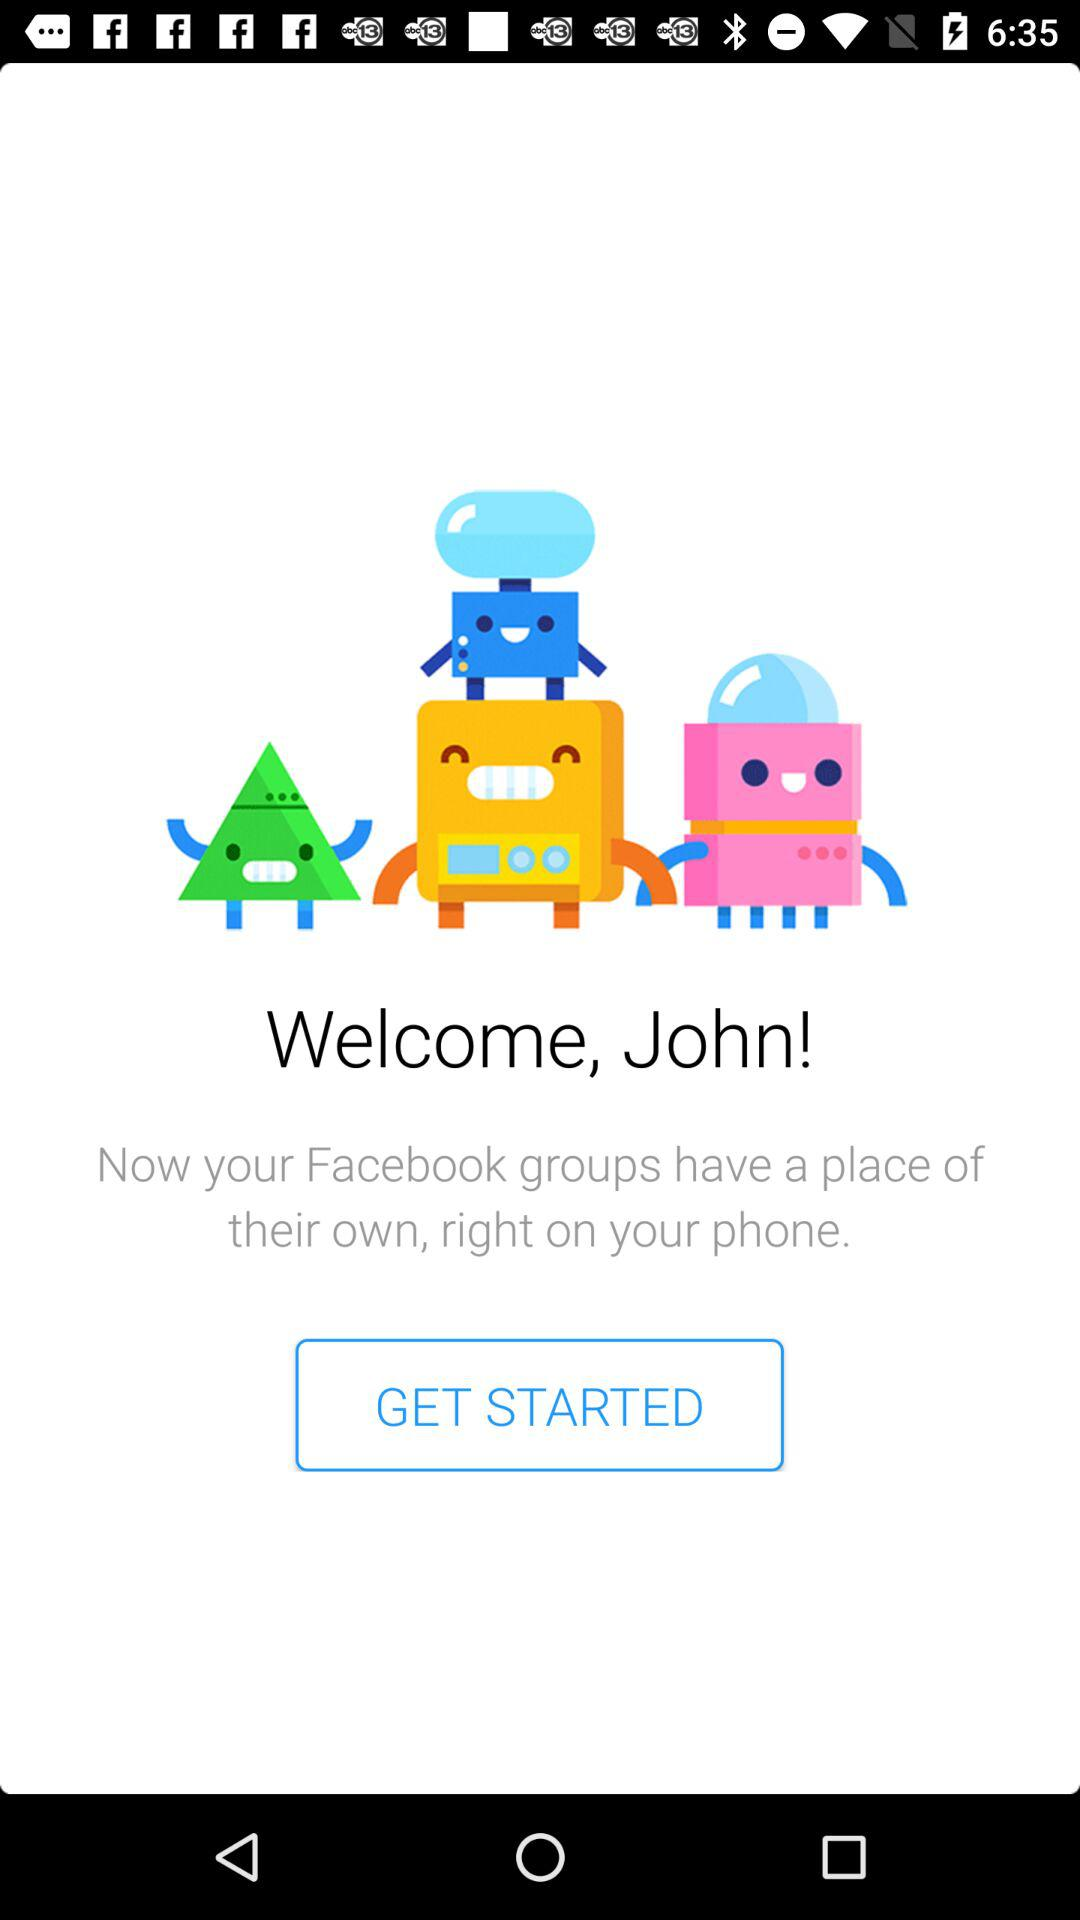What is the name of the application? The name of the application is "Facebook". 